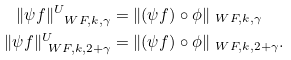Convert formula to latex. <formula><loc_0><loc_0><loc_500><loc_500>\| \psi f \| ^ { U } _ { \ W F , k , \gamma } & = \| ( \psi f ) \circ \phi \| _ { \ W F , k , \gamma } \\ \| \psi f \| ^ { U } _ { \ W F , k , 2 + \gamma } & = \| ( \psi f ) \circ \phi \| _ { \ W F , k , 2 + \gamma } .</formula> 